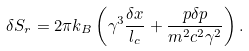<formula> <loc_0><loc_0><loc_500><loc_500>\delta S _ { r } = 2 \pi k _ { B } \left ( \gamma ^ { 3 } \frac { \delta x } { l _ { c } } + \frac { p \delta p } { m ^ { 2 } c ^ { 2 } \gamma ^ { 2 } } \right ) .</formula> 